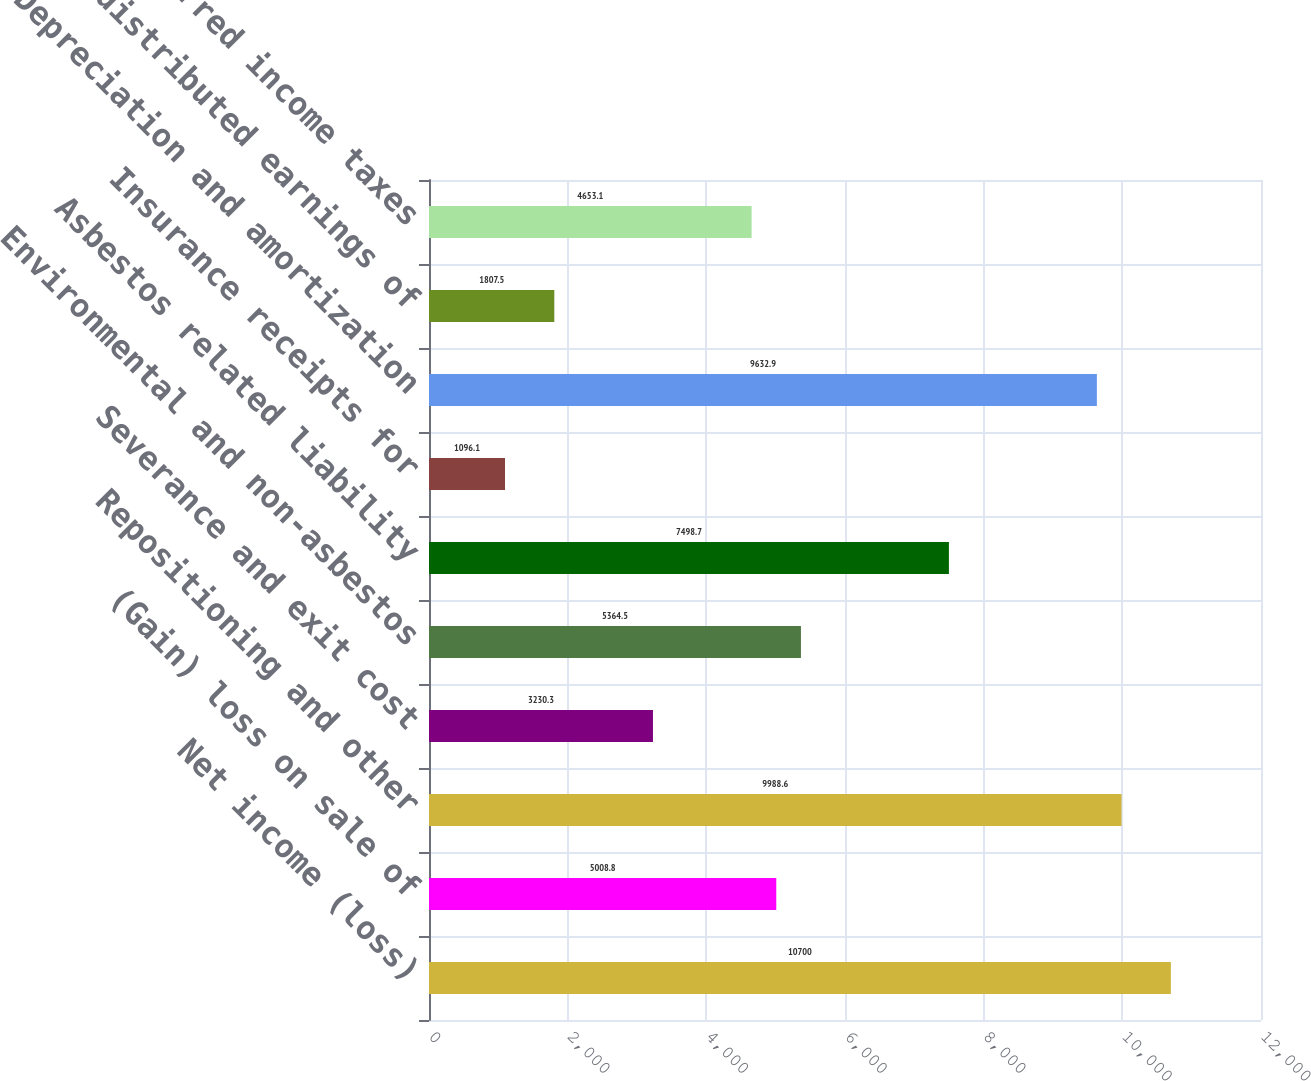Convert chart. <chart><loc_0><loc_0><loc_500><loc_500><bar_chart><fcel>Net income (loss)<fcel>(Gain) loss on sale of<fcel>Repositioning and other<fcel>Severance and exit cost<fcel>Environmental and non-asbestos<fcel>Asbestos related liability<fcel>Insurance receipts for<fcel>Depreciation and amortization<fcel>Undistributed earnings of<fcel>Deferred income taxes<nl><fcel>10700<fcel>5008.8<fcel>9988.6<fcel>3230.3<fcel>5364.5<fcel>7498.7<fcel>1096.1<fcel>9632.9<fcel>1807.5<fcel>4653.1<nl></chart> 